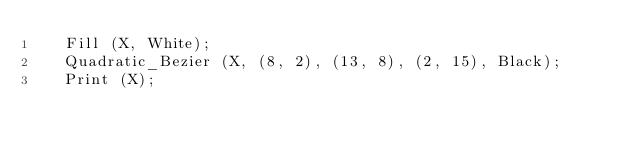<code> <loc_0><loc_0><loc_500><loc_500><_Ada_>   Fill (X, White);
   Quadratic_Bezier (X, (8, 2), (13, 8), (2, 15), Black);
   Print (X);
</code> 